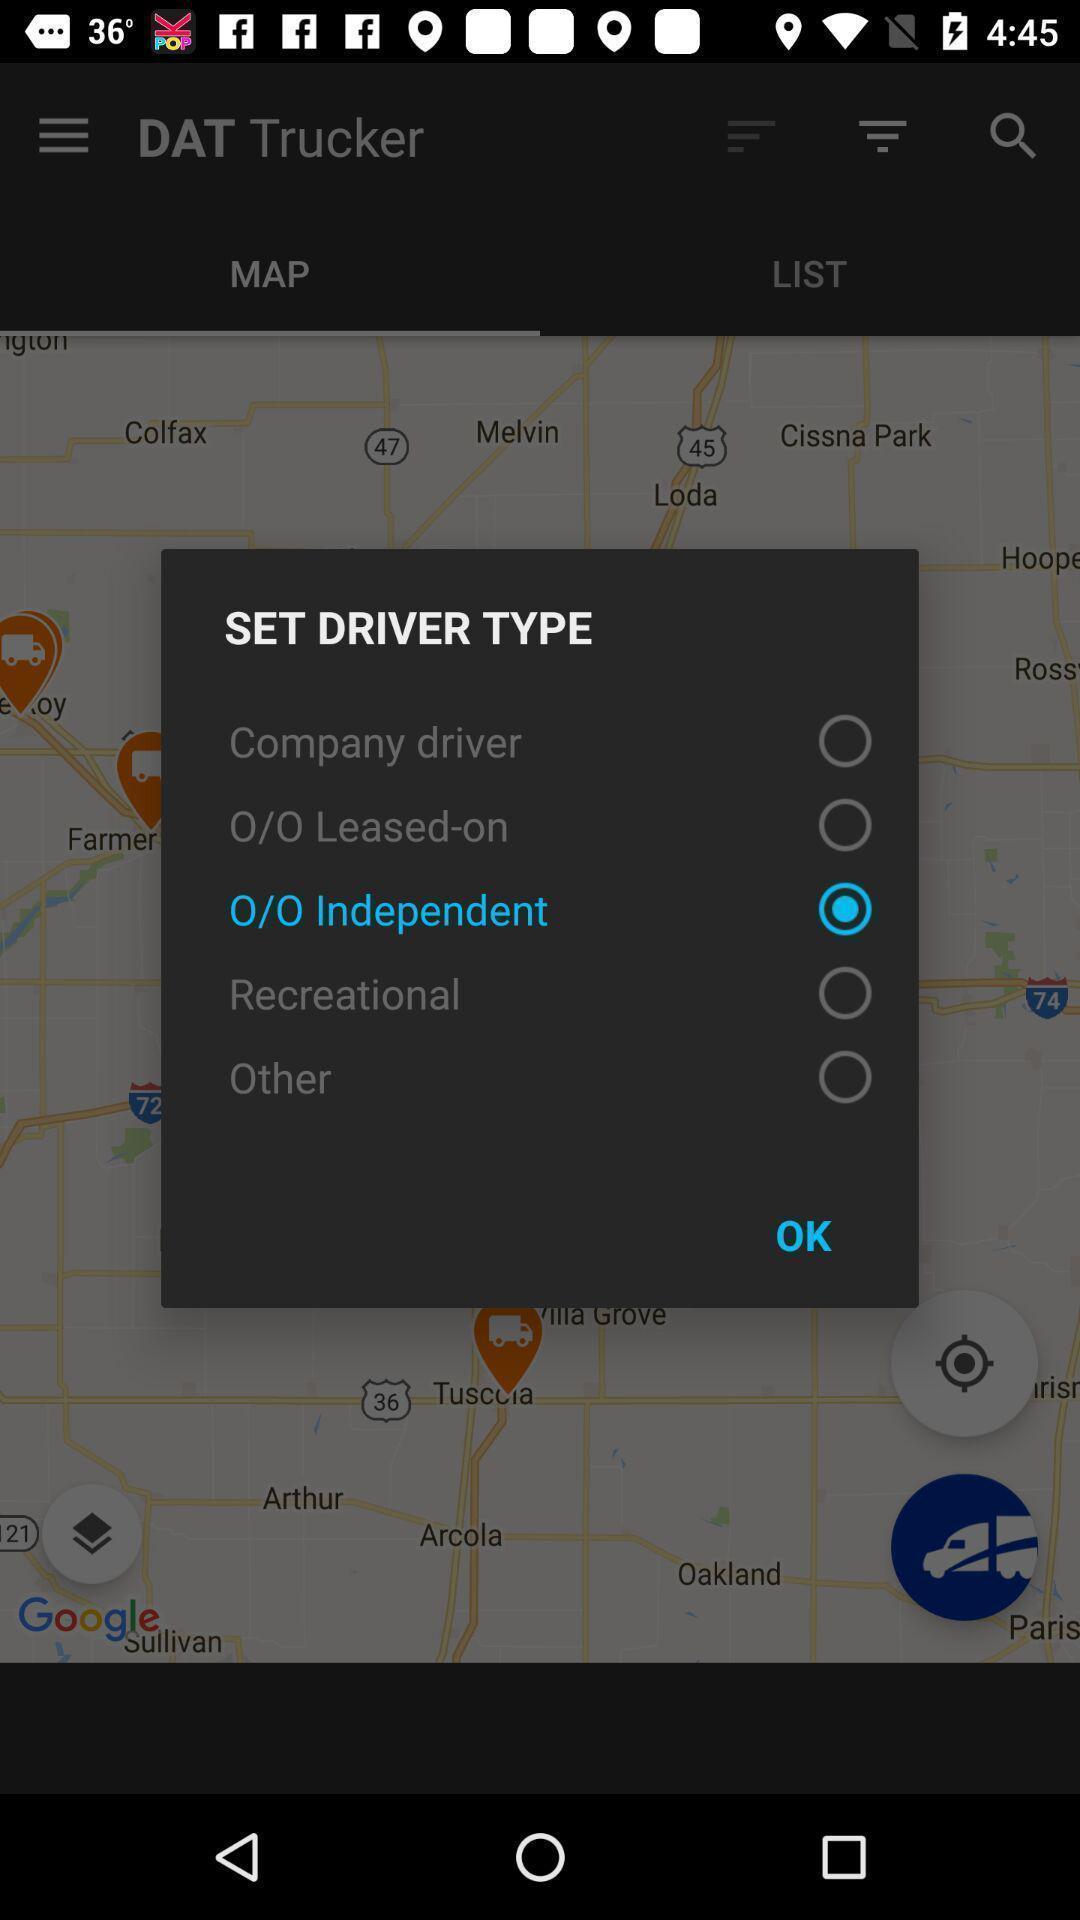Summarize the main components in this picture. Popup page for choosing a driver type. 